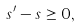<formula> <loc_0><loc_0><loc_500><loc_500>s ^ { \prime } - s \geq 0 ,</formula> 